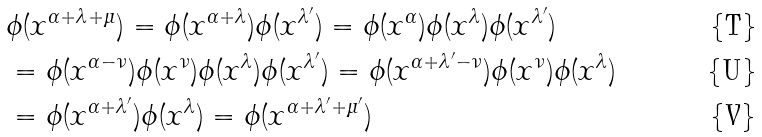Convert formula to latex. <formula><loc_0><loc_0><loc_500><loc_500>& \phi ( x ^ { \alpha + \lambda + \mu } ) = \phi ( x ^ { \alpha + \lambda } ) \phi ( x ^ { \lambda ^ { \prime } } ) = \phi ( x ^ { \alpha } ) \phi ( x ^ { \lambda } ) \phi ( x ^ { \lambda ^ { \prime } } ) \\ & = \phi ( x ^ { \alpha - \nu } ) \phi ( x ^ { \nu } ) \phi ( x ^ { \lambda } ) \phi ( x ^ { \lambda ^ { \prime } } ) = \phi ( x ^ { \alpha + \lambda ^ { \prime } - \nu } ) \phi ( x ^ { \nu } ) \phi ( x ^ { \lambda } ) \\ & = \phi ( x ^ { \alpha + \lambda ^ { \prime } } ) \phi ( x ^ { \lambda } ) = \phi ( x ^ { \alpha + \lambda ^ { \prime } + \mu ^ { \prime } } )</formula> 